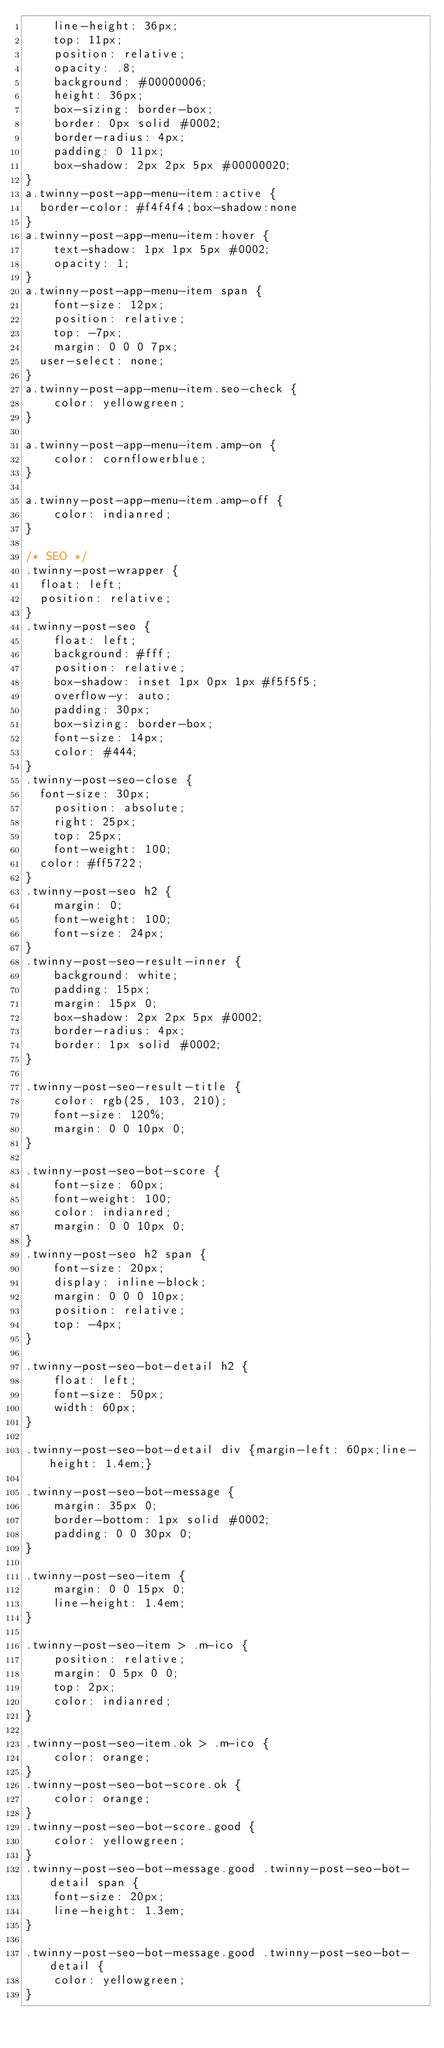Convert code to text. <code><loc_0><loc_0><loc_500><loc_500><_CSS_>    line-height: 36px;
    top: 11px;
    position: relative;
    opacity: .8;
    background: #00000006;
    height: 36px;
    box-sizing: border-box;
    border: 0px solid #0002;
    border-radius: 4px;
    padding: 0 11px;
    box-shadow: 2px 2px 5px #00000020;
}
a.twinny-post-app-menu-item:active {
	border-color: #f4f4f4;box-shadow:none
}
a.twinny-post-app-menu-item:hover {    
    text-shadow: 1px 1px 5px #0002;
    opacity: 1;
}
a.twinny-post-app-menu-item span {
    font-size: 12px;
    position: relative;
    top: -7px;
    margin: 0 0 0 7px;
	user-select: none;
}
a.twinny-post-app-menu-item.seo-check {
    color: yellowgreen;
}

a.twinny-post-app-menu-item.amp-on {
    color: cornflowerblue;
}

a.twinny-post-app-menu-item.amp-off {
    color: indianred;
}

/* SEO */
.twinny-post-wrapper {
	float: left;
	position: relative;
}
.twinny-post-seo {
    float: left;
    background: #fff;
    position: relative;
    box-shadow: inset 1px 0px 1px #f5f5f5;
    overflow-y: auto;
    padding: 30px;
    box-sizing: border-box;
    font-size: 14px;
    color: #444;
}
.twinny-post-seo-close {
	font-size: 30px;
    position: absolute;
    right: 25px;
    top: 25px;
    font-weight: 100;
	color: #ff5722;
}
.twinny-post-seo h2 {
    margin: 0;
    font-weight: 100;
    font-size: 24px;
}
.twinny-post-seo-result-inner {
    background: white;
    padding: 15px;
    margin: 15px 0;
    box-shadow: 2px 2px 5px #0002;
    border-radius: 4px;
    border: 1px solid #0002;
}

.twinny-post-seo-result-title {
    color: rgb(25, 103, 210);
    font-size: 120%;
    margin: 0 0 10px 0;
}

.twinny-post-seo-bot-score {
    font-size: 60px;
    font-weight: 100;
    color: indianred;
    margin: 0 0 10px 0;
}
.twinny-post-seo h2 span {
    font-size: 20px;
    display: inline-block;
    margin: 0 0 0 10px;
    position: relative;
    top: -4px;
}

.twinny-post-seo-bot-detail h2 {
    float: left;
    font-size: 50px;
    width: 60px;
}

.twinny-post-seo-bot-detail div {margin-left: 60px;line-height: 1.4em;}

.twinny-post-seo-bot-message {
    margin: 35px 0;
    border-bottom: 1px solid #0002;
    padding: 0 0 30px 0;
}

.twinny-post-seo-item {
    margin: 0 0 15px 0;
    line-height: 1.4em;
}

.twinny-post-seo-item > .m-ico {
    position: relative;
    margin: 0 5px 0 0;
    top: 2px;
    color: indianred;
}

.twinny-post-seo-item.ok > .m-ico {
    color: orange;
}
.twinny-post-seo-bot-score.ok {
    color: orange;
}
.twinny-post-seo-bot-score.good {
    color: yellowgreen;
}
.twinny-post-seo-bot-message.good .twinny-post-seo-bot-detail span {
    font-size: 20px;
    line-height: 1.3em;
}

.twinny-post-seo-bot-message.good .twinny-post-seo-bot-detail {
    color: yellowgreen;
}</code> 